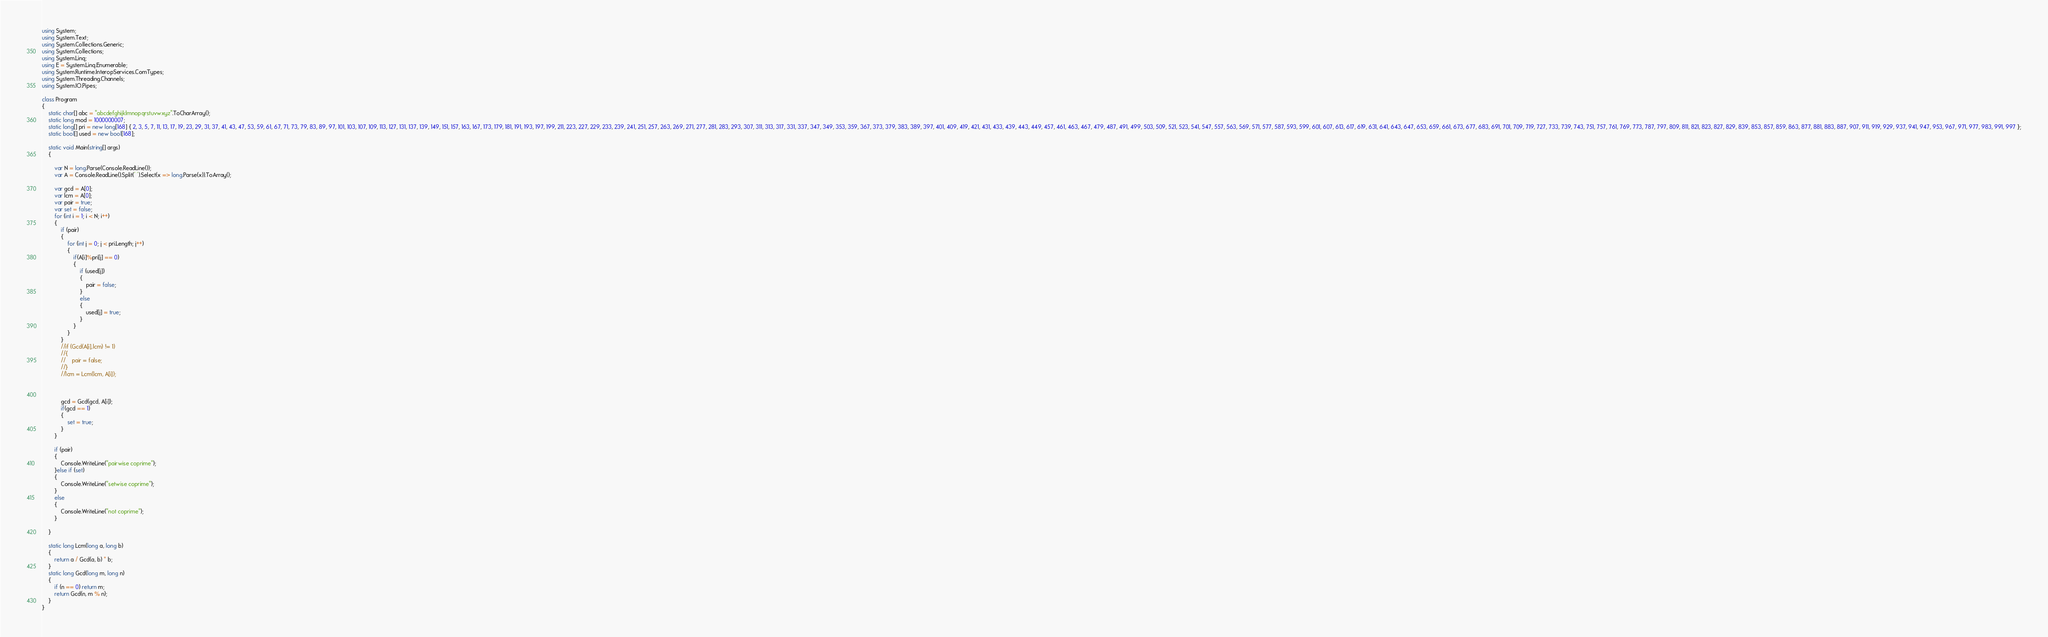<code> <loc_0><loc_0><loc_500><loc_500><_C#_>using System;
using System.Text;
using System.Collections.Generic;
using System.Collections;
using System.Linq;
using E = System.Linq.Enumerable;
using System.Runtime.InteropServices.ComTypes;
using System.Threading.Channels;
using System.IO.Pipes;

class Program
{
    static char[] abc = "abcdefghijklmnopqrstuvwxyz".ToCharArray();
    static long mod = 1000000007;
    static long[] pri = new long[168] { 2, 3, 5, 7, 11, 13, 17, 19, 23, 29, 31, 37, 41, 43, 47, 53, 59, 61, 67, 71, 73, 79, 83, 89, 97, 101, 103, 107, 109, 113, 127, 131, 137, 139, 149, 151, 157, 163, 167, 173, 179, 181, 191, 193, 197, 199, 211, 223, 227, 229, 233, 239, 241, 251, 257, 263, 269, 271, 277, 281, 283, 293, 307, 311, 313, 317, 331, 337, 347, 349, 353, 359, 367, 373, 379, 383, 389, 397, 401, 409, 419, 421, 431, 433, 439, 443, 449, 457, 461, 463, 467, 479, 487, 491, 499, 503, 509, 521, 523, 541, 547, 557, 563, 569, 571, 577, 587, 593, 599, 601, 607, 613, 617, 619, 631, 641, 643, 647, 653, 659, 661, 673, 677, 683, 691, 701, 709, 719, 727, 733, 739, 743, 751, 757, 761, 769, 773, 787, 797, 809, 811, 821, 823, 827, 829, 839, 853, 857, 859, 863, 877, 881, 883, 887, 907, 911, 919, 929, 937, 941, 947, 953, 967, 971, 977, 983, 991, 997 };
    static bool[] used = new bool[168];

    static void Main(string[] args)
    {

        var N = long.Parse(Console.ReadLine());
        var A = Console.ReadLine().Split(' ').Select(x => long.Parse(x)).ToArray();

        var gcd = A[0];
        var lcm = A[0];
        var pair = true;
        var set = false;
        for (int i = 1; i < N; i++)
        {
            if (pair)
            {
                for (int j = 0; j < pri.Length; j++)
                {
                    if(A[i]%pri[j] == 0)
                    {
                        if (used[j])
                        {
                            pair = false;
                        }
                        else
                        {
                            used[j] = true;
                        }
                    }
                }
            }
            //if (Gcd(A[i],lcm) != 1)
            //{
            //    pair = false;
            //}
            //lcm = Lcm(lcm, A[i]);



            gcd = Gcd(gcd, A[i]);
            if(gcd == 1)
            {
                set = true;
            }
        }

        if (pair)
        {
            Console.WriteLine("pairwise coprime");
        }else if (set)
        {
            Console.WriteLine("setwise coprime");
        }
        else
        {
            Console.WriteLine("not coprime");
        }
        
    }

    static long Lcm(long a, long b)
    {
        return a / Gcd(a, b) * b;
    }
    static long Gcd(long m, long n)
    {
        if (n == 0) return m;
        return Gcd(n, m % n);
    }
}


</code> 